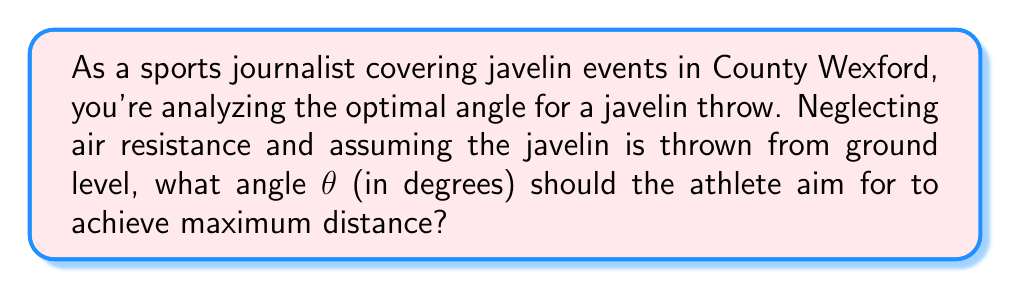What is the answer to this math problem? To determine the optimal angle for a javelin throw, we need to consider the principles of projectile motion. The distance traveled by a projectile launched from ground level is given by the equation:

$$d = \frac{v_0^2 \sin(2\theta)}{g}$$

Where:
$d$ is the distance traveled
$v_0$ is the initial velocity
$\theta$ is the launch angle
$g$ is the acceleration due to gravity

To find the maximum distance, we need to maximize $\sin(2\theta)$. The sine function reaches its maximum value of 1 when its argument is 90°. Therefore:

$$2\theta = 90°$$
$$\theta = 45°$$

This result can be understood intuitively:
1. If the angle is too low, the javelin will hit the ground too soon.
2. If the angle is too high, the javelin will spend too much time going up and not enough time traveling horizontally.
3. 45° balances these factors, providing the optimal trade-off between vertical and horizontal motion.

It's worth noting that in real-world scenarios, factors such as air resistance, the aerodynamics of the javelin, and the release height can slightly modify this optimal angle. However, 45° remains a good approximation for most practical purposes.

[asy]
import geometry;

size(200);
draw((0,0)--(100,100), arrow=Arrow(TeXHead));
draw((0,0)--(141,0), arrow=Arrow(TeXHead));
draw((0,0)--(100,0), dashed);
draw((100,0)--(100,100), dashed);

label("45°", (20,20), NE);
label("Javelin trajectory", (70,80), N);
label("Ground", (70,0), S);
[/asy]
Answer: 45° 